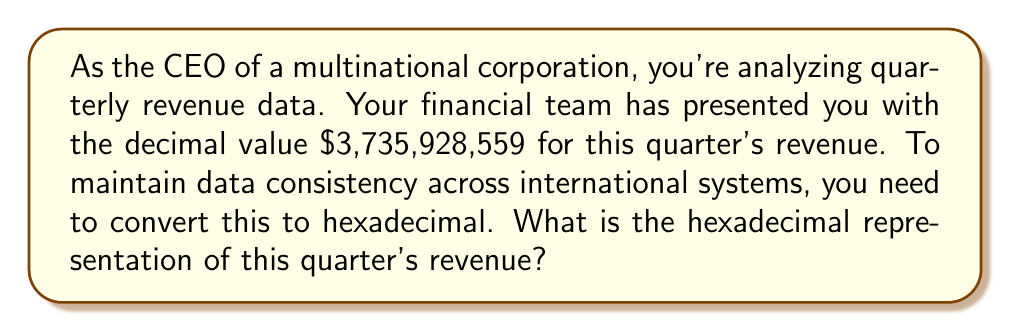Teach me how to tackle this problem. To convert a decimal number to hexadecimal, we follow these steps:

1) Divide the decimal number by 16 repeatedly until the quotient becomes 0.
2) Write down the remainders in reverse order.

Let's perform the division:

$$3,735,928,559 \div 16 = 233,495,534 \text{ remainder } 15 \text{ (F)}$$
$$233,495,534 \div 16 = 14,593,470 \text{ remainder } 14 \text{ (E)}$$
$$14,593,470 \div 16 = 912,091 \text{ remainder } 14 \text{ (E)}$$
$$912,091 \div 16 = 57,005 \text{ remainder } 11 \text{ (B)}$$
$$57,005 \div 16 = 3,562 \text{ remainder } 13 \text{ (D)}$$
$$3,562 \div 16 = 222 \text{ remainder } 10 \text{ (A)}$$
$$222 \div 16 = 13 \text{ remainder } 14 \text{ (E)}$$
$$13 \div 16 = 0 \text{ remainder } 13 \text{ (D)}$$

Now, reading the remainders from bottom to top, we get:

$$\text{DE}ABDEEF_{16}$$

This is the hexadecimal representation of the decimal number 3,735,928,559.
Answer: $\text{DE}ABDEEF_{16}$ 